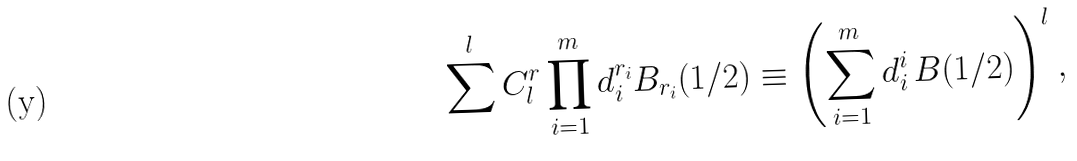<formula> <loc_0><loc_0><loc_500><loc_500>\sum ^ { l } C _ { l } ^ { r } \prod _ { i = 1 } ^ { m } d _ { i } ^ { r _ { i } } B _ { r _ { i } } ( 1 / 2 ) \equiv \left ( \sum _ { i = 1 } ^ { m } d _ { i } ^ { i } \, B ( 1 / 2 ) \right ) ^ { l } ,</formula> 